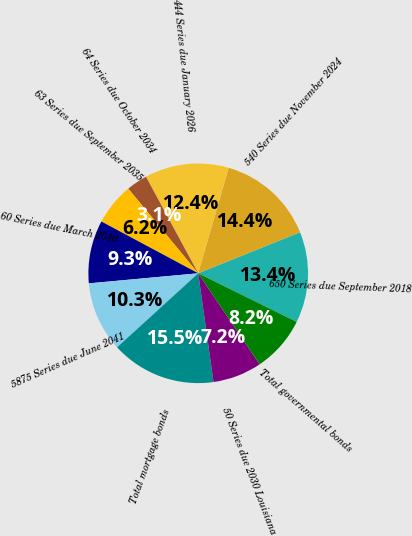<chart> <loc_0><loc_0><loc_500><loc_500><pie_chart><fcel>650 Series due September 2018<fcel>540 Series due November 2024<fcel>444 Series due January 2026<fcel>64 Series due October 2034<fcel>63 Series due September 2035<fcel>60 Series due March 2040<fcel>5875 Series due June 2041<fcel>Total mortgage bonds<fcel>50 Series due 2030 Louisiana<fcel>Total governmental bonds<nl><fcel>13.4%<fcel>14.43%<fcel>12.37%<fcel>3.1%<fcel>6.19%<fcel>9.28%<fcel>10.31%<fcel>15.46%<fcel>7.22%<fcel>8.25%<nl></chart> 